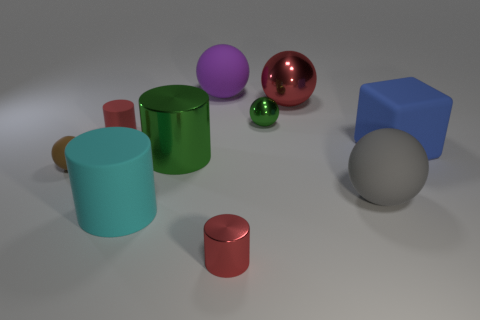The large rubber thing that is both behind the gray matte object and left of the gray rubber ball has what shape?
Offer a very short reply. Sphere. Is there anything else that has the same material as the large red object?
Your answer should be very brief. Yes. Is the number of big red metal balls the same as the number of yellow matte things?
Keep it short and to the point. No. What is the material of the ball that is both in front of the big blue thing and left of the small green ball?
Keep it short and to the point. Rubber. What shape is the small green thing that is the same material as the large green thing?
Your answer should be very brief. Sphere. Is there any other thing that is the same color as the big metal cylinder?
Offer a very short reply. Yes. Are there more large purple balls that are left of the large matte cylinder than tiny yellow rubber things?
Offer a very short reply. No. What material is the tiny green sphere?
Make the answer very short. Metal. How many rubber cubes have the same size as the red metallic cylinder?
Provide a short and direct response. 0. Are there an equal number of brown objects that are on the right side of the big cyan cylinder and rubber cylinders that are to the left of the small red rubber cylinder?
Your response must be concise. Yes. 